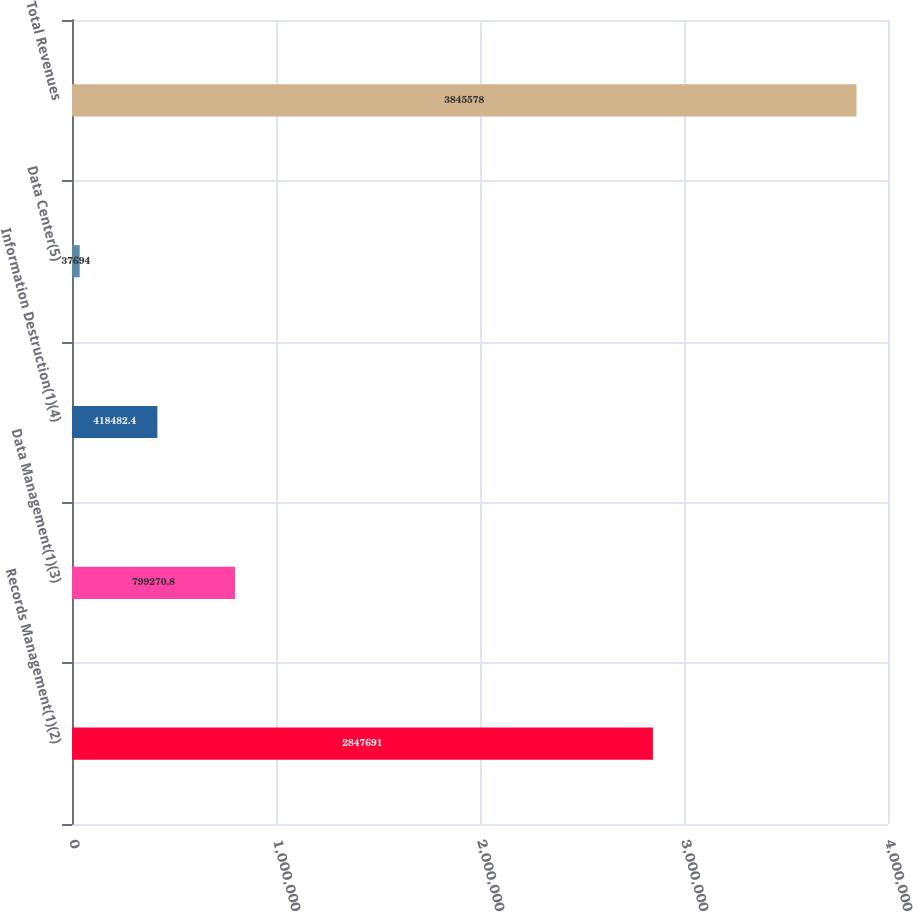<chart> <loc_0><loc_0><loc_500><loc_500><bar_chart><fcel>Records Management(1)(2)<fcel>Data Management(1)(3)<fcel>Information Destruction(1)(4)<fcel>Data Center(5)<fcel>Total Revenues<nl><fcel>2.84769e+06<fcel>799271<fcel>418482<fcel>37694<fcel>3.84558e+06<nl></chart> 